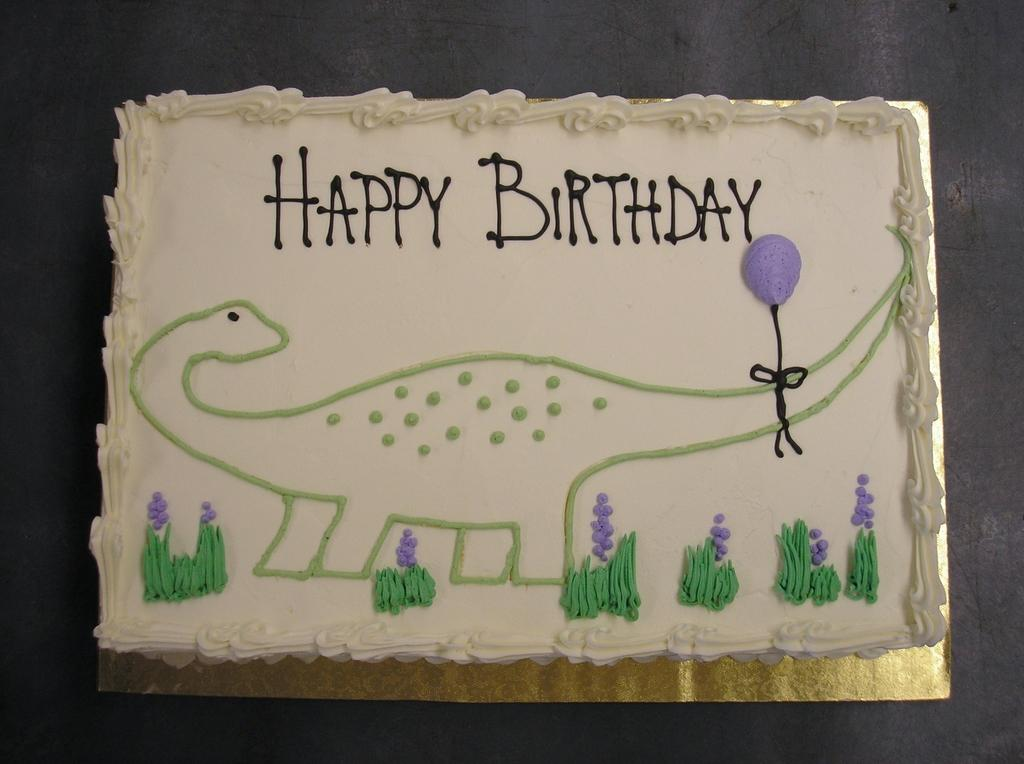What is the main subject of the image? There is a cake in the image. What is the cake placed on? The cake is placed on golden cardboard. Is there any text or message on the cake? Yes, there is writing on the cake. What decoration can be seen on the cake? There is a dragon depicted on the cake. What is the color of the surface the cake is placed on? The cake is placed on a black surface. What type of plastic material is covering the cake in the image? There is no plastic material covering the cake in the image. What color is the powder sprinkled on the cake in the image? There is no powder sprinkled on the cake in the image. 